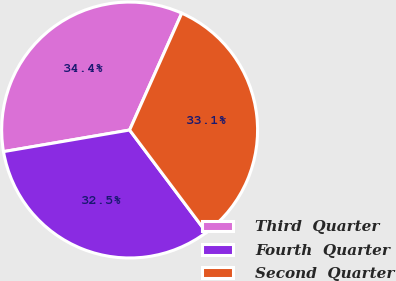Convert chart. <chart><loc_0><loc_0><loc_500><loc_500><pie_chart><fcel>Third  Quarter<fcel>Fourth  Quarter<fcel>Second  Quarter<nl><fcel>34.38%<fcel>32.54%<fcel>33.08%<nl></chart> 